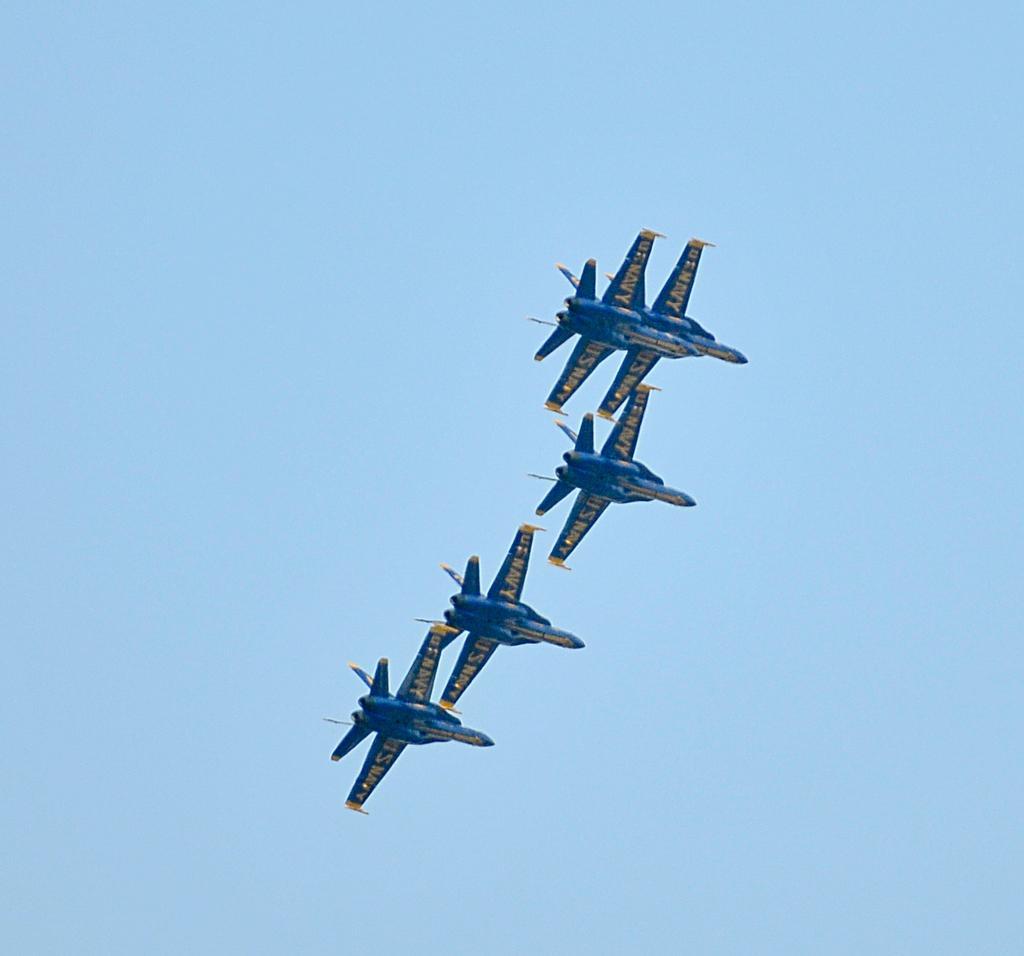In one or two sentences, can you explain what this image depicts? In the picture we can see a sky and five aircrafts are flying which are blue in color. 